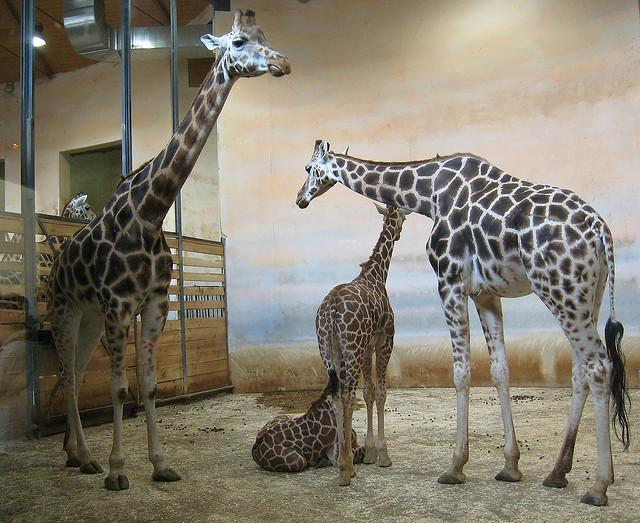What kind of venue is this? zoo 